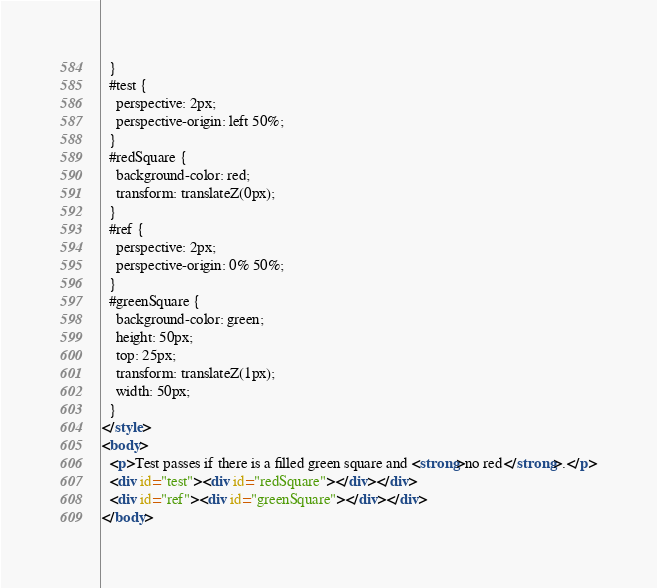Convert code to text. <code><loc_0><loc_0><loc_500><loc_500><_HTML_>  }
  #test {
    perspective: 2px;
    perspective-origin: left 50%;
  }
  #redSquare {
    background-color: red;
    transform: translateZ(0px);
  }
  #ref {
    perspective: 2px;
    perspective-origin: 0% 50%;
  }
  #greenSquare {
    background-color: green;
    height: 50px;
    top: 25px;
    transform: translateZ(1px);
    width: 50px;
  }
</style>
<body>
  <p>Test passes if there is a filled green square and <strong>no red</strong>.</p>
  <div id="test"><div id="redSquare"></div></div>
  <div id="ref"><div id="greenSquare"></div></div>
</body>
</code> 